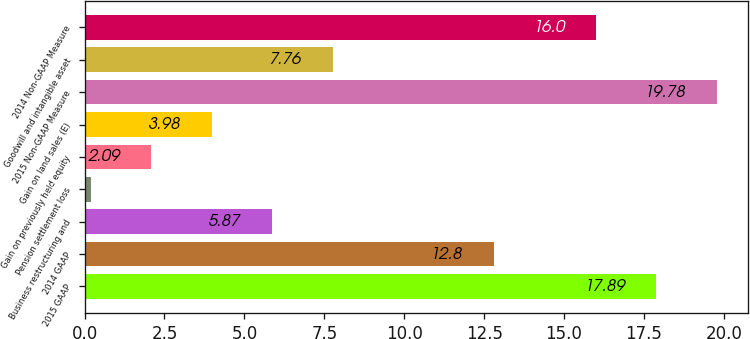Convert chart to OTSL. <chart><loc_0><loc_0><loc_500><loc_500><bar_chart><fcel>2015 GAAP<fcel>2014 GAAP<fcel>Business restructuring and<fcel>Pension settlement loss<fcel>Gain on previously held equity<fcel>Gain on land sales (E)<fcel>2015 Non-GAAP Measure<fcel>Goodwill and intangible asset<fcel>2014 Non-GAAP Measure<nl><fcel>17.89<fcel>12.8<fcel>5.87<fcel>0.2<fcel>2.09<fcel>3.98<fcel>19.78<fcel>7.76<fcel>16<nl></chart> 